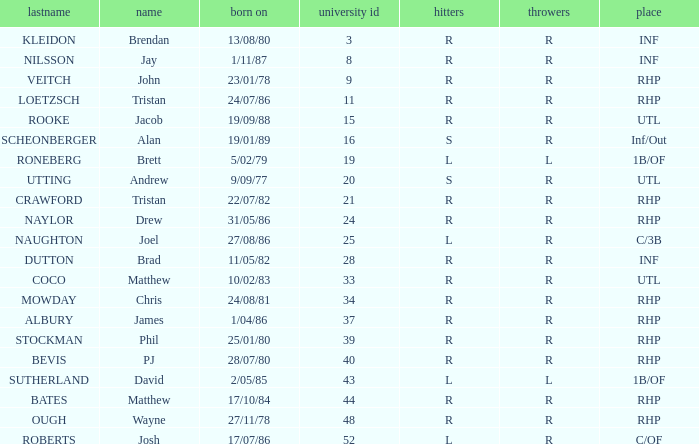How many Uni numbers have Bats of s, and a Position of utl? 1.0. 